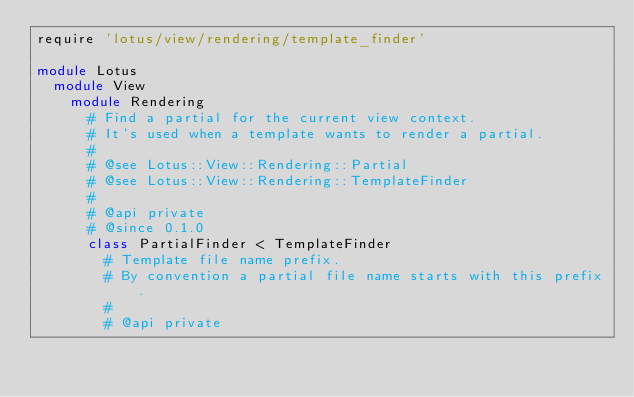<code> <loc_0><loc_0><loc_500><loc_500><_Ruby_>require 'lotus/view/rendering/template_finder'

module Lotus
  module View
    module Rendering
      # Find a partial for the current view context.
      # It's used when a template wants to render a partial.
      #
      # @see Lotus::View::Rendering::Partial
      # @see Lotus::View::Rendering::TemplateFinder
      #
      # @api private
      # @since 0.1.0
      class PartialFinder < TemplateFinder
        # Template file name prefix.
        # By convention a partial file name starts with this prefix.
        #
        # @api private</code> 